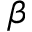<formula> <loc_0><loc_0><loc_500><loc_500>\beta</formula> 